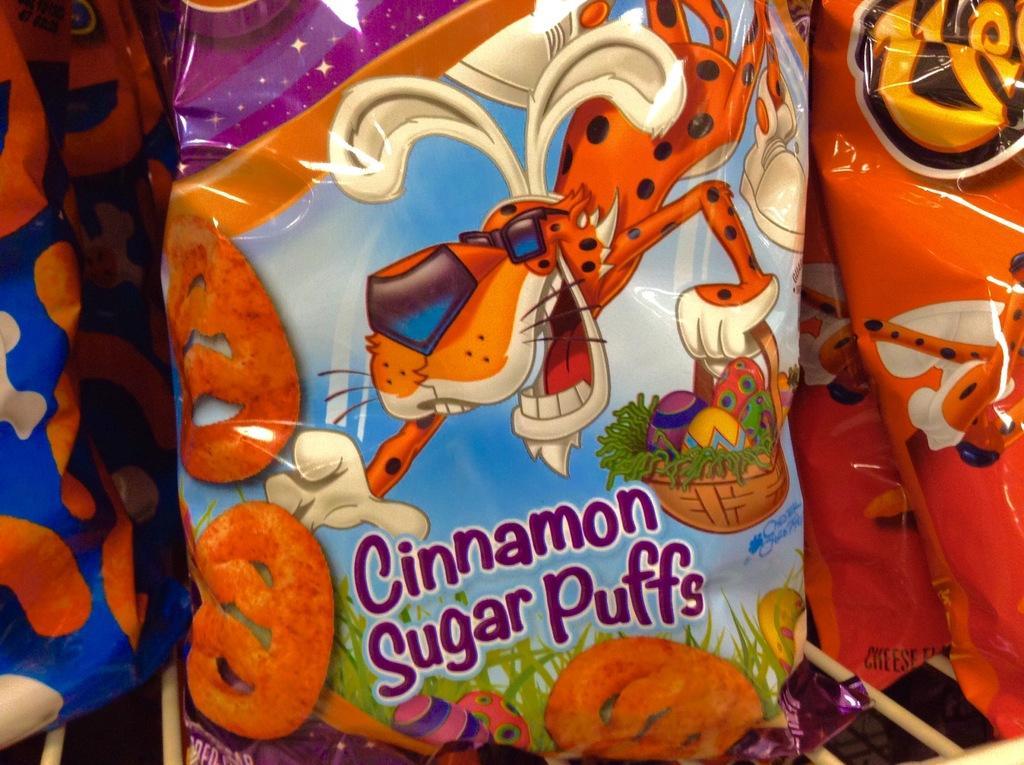In one or two sentences, can you explain what this image depicts? In the picture we can see a snacks packet on it we can see some paintings of cartoons. 